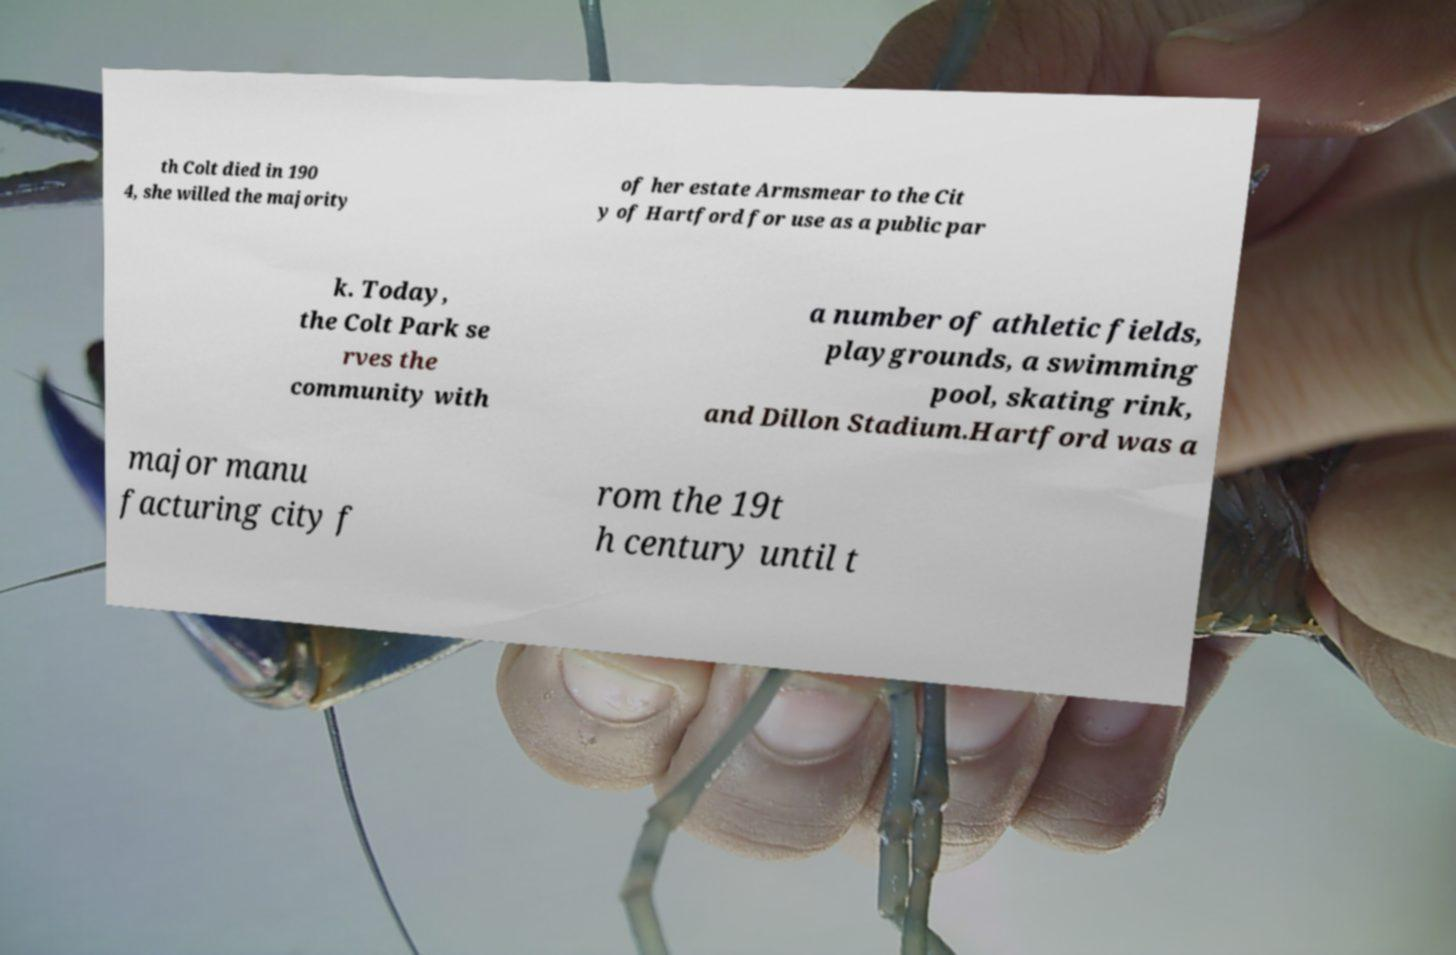Please read and relay the text visible in this image. What does it say? th Colt died in 190 4, she willed the majority of her estate Armsmear to the Cit y of Hartford for use as a public par k. Today, the Colt Park se rves the community with a number of athletic fields, playgrounds, a swimming pool, skating rink, and Dillon Stadium.Hartford was a major manu facturing city f rom the 19t h century until t 